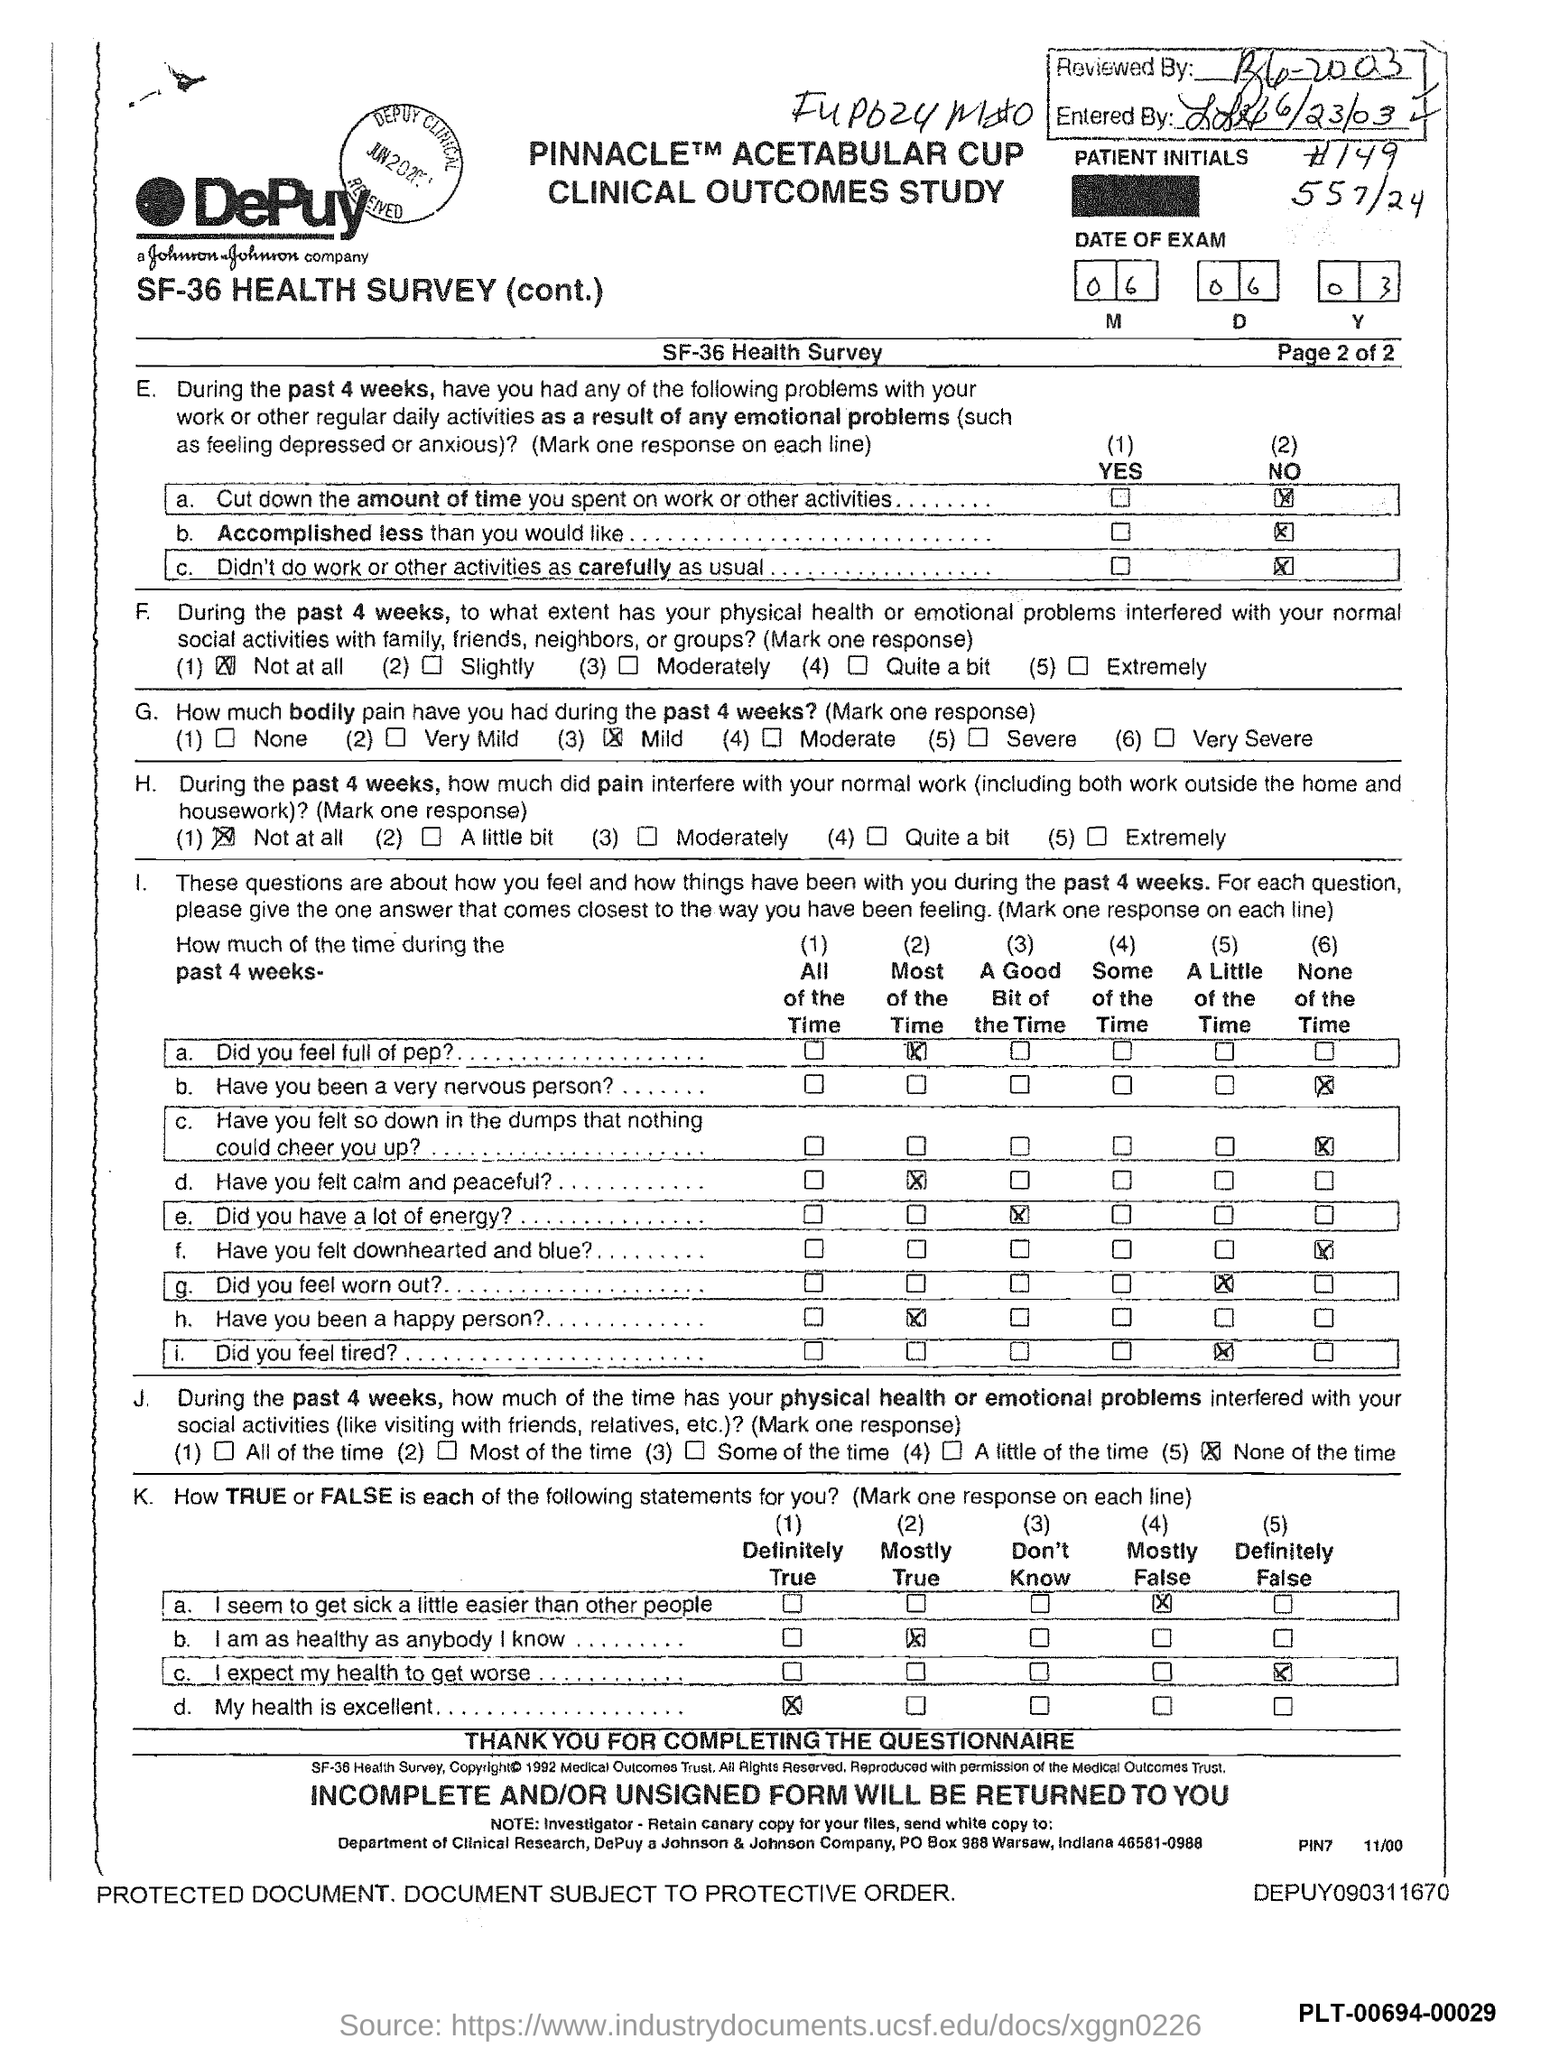What is the date of the exam mentioned in the document?
Your answer should be very brief. 06 06 03. How much bodily pain have you had during the past 4 weeks as per the health survey?
Keep it short and to the point. Mild. 